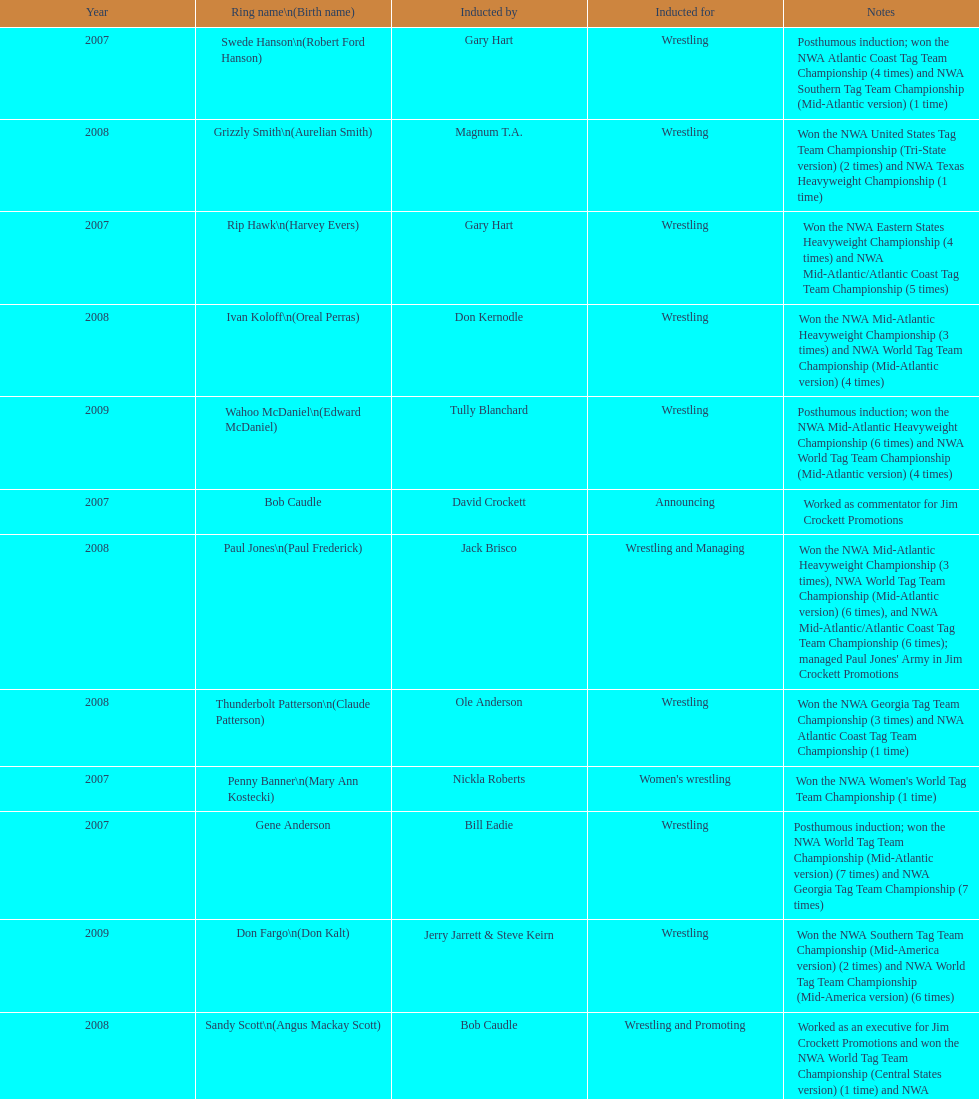Whose genuine name is dale hey, grizzly smith, or buddy roberts? Buddy Roberts. 